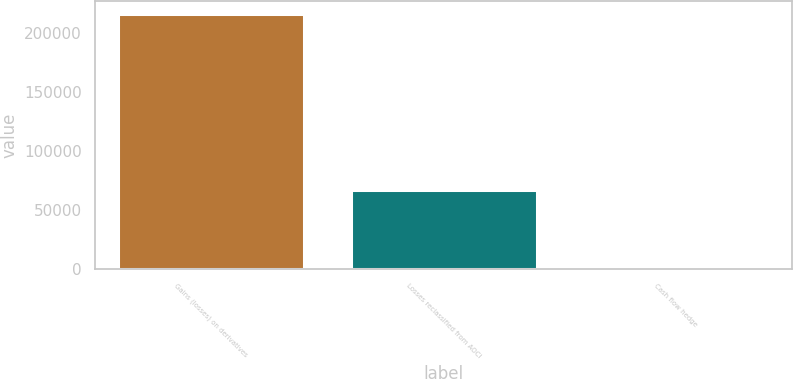Convert chart. <chart><loc_0><loc_0><loc_500><loc_500><bar_chart><fcel>Gains (losses) on derivatives<fcel>Losses reclassified from AOCI<fcel>Cash flow hedge<nl><fcel>216302<fcel>66847<fcel>491<nl></chart> 